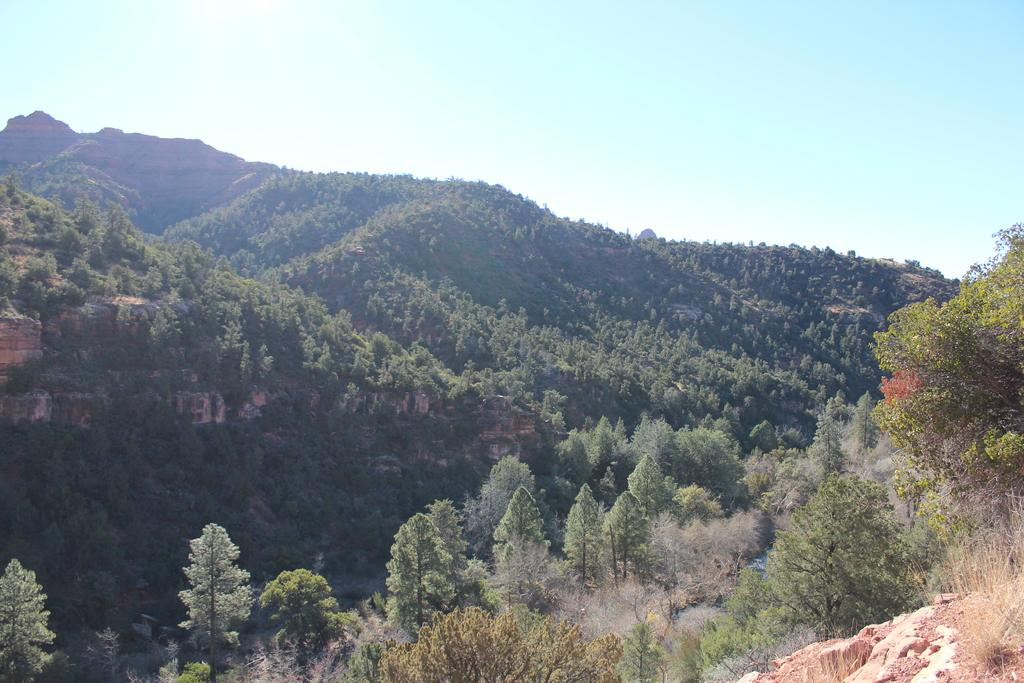What type of natural environment is depicted in the image? The image features many trees, a rock, and mountains, indicating a natural landscape. Can you describe the sky in the image? The blue sky is visible in the background of the image. What type of geological feature can be seen in the image? There are mountains in the image. What type of engine can be seen powering the rock in the image? There is no engine present in the image, and the rock is not being powered by any engine. 